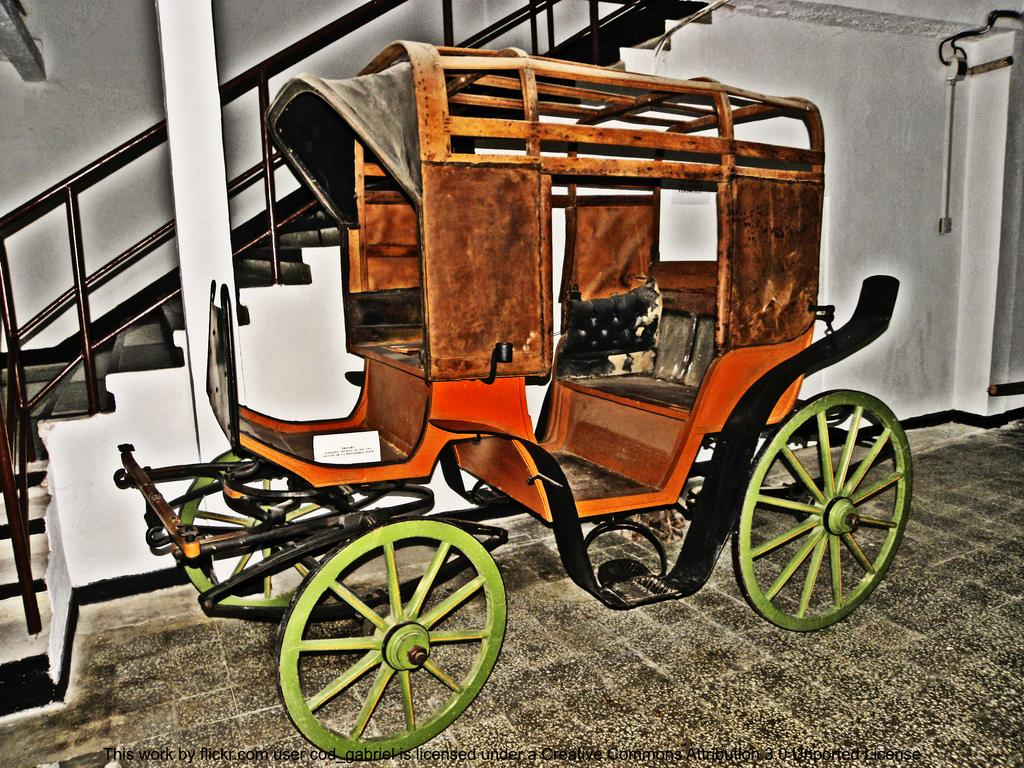What object is on the floor in the image? There is a cart on the floor. What architectural feature can be seen in the background of the image? There is a staircase in the background. What other objects can be seen in the background of the image? There is a pillar and a pipe on the wall in the background. What date is marked on the calendar in the image? There is no calendar present in the image. Can you see the moon in the image? The image does not show the moon; it only features a cart on the floor, a staircase, a pillar, and a pipe on the wall in the background. 